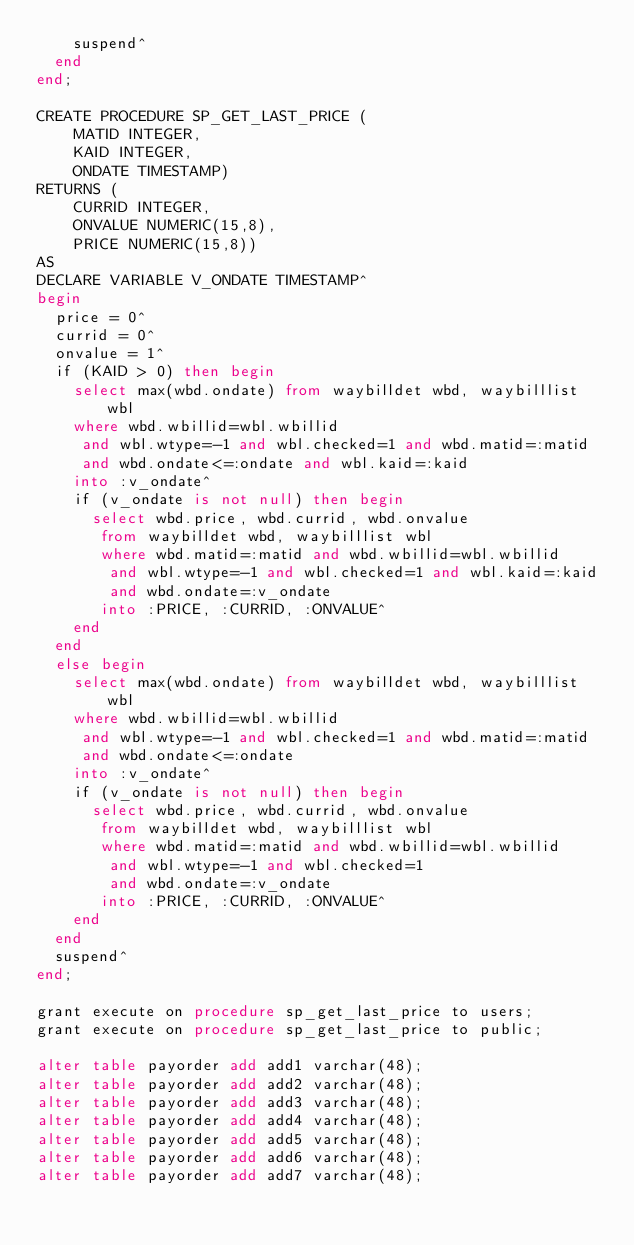<code> <loc_0><loc_0><loc_500><loc_500><_SQL_>    suspend^
  end
end;

CREATE PROCEDURE SP_GET_LAST_PRICE (
    MATID INTEGER,
    KAID INTEGER,
    ONDATE TIMESTAMP)
RETURNS (
    CURRID INTEGER,
    ONVALUE NUMERIC(15,8),
    PRICE NUMERIC(15,8))
AS
DECLARE VARIABLE V_ONDATE TIMESTAMP^
begin
  price = 0^
  currid = 0^
  onvalue = 1^
  if (KAID > 0) then begin
    select max(wbd.ondate) from waybilldet wbd, waybilllist wbl
    where wbd.wbillid=wbl.wbillid
     and wbl.wtype=-1 and wbl.checked=1 and wbd.matid=:matid
     and wbd.ondate<=:ondate and wbl.kaid=:kaid
    into :v_ondate^
    if (v_ondate is not null) then begin
      select wbd.price, wbd.currid, wbd.onvalue
       from waybilldet wbd, waybilllist wbl
       where wbd.matid=:matid and wbd.wbillid=wbl.wbillid
        and wbl.wtype=-1 and wbl.checked=1 and wbl.kaid=:kaid
        and wbd.ondate=:v_ondate
       into :PRICE, :CURRID, :ONVALUE^
    end
  end
  else begin
    select max(wbd.ondate) from waybilldet wbd, waybilllist wbl
    where wbd.wbillid=wbl.wbillid
     and wbl.wtype=-1 and wbl.checked=1 and wbd.matid=:matid
     and wbd.ondate<=:ondate
    into :v_ondate^
    if (v_ondate is not null) then begin
      select wbd.price, wbd.currid, wbd.onvalue
       from waybilldet wbd, waybilllist wbl
       where wbd.matid=:matid and wbd.wbillid=wbl.wbillid
        and wbl.wtype=-1 and wbl.checked=1
        and wbd.ondate=:v_ondate
       into :PRICE, :CURRID, :ONVALUE^
    end
  end
  suspend^
end;

grant execute on procedure sp_get_last_price to users;
grant execute on procedure sp_get_last_price to public;

alter table payorder add add1 varchar(48);
alter table payorder add add2 varchar(48);
alter table payorder add add3 varchar(48);
alter table payorder add add4 varchar(48);
alter table payorder add add5 varchar(48);
alter table payorder add add6 varchar(48);
alter table payorder add add7 varchar(48);

</code> 